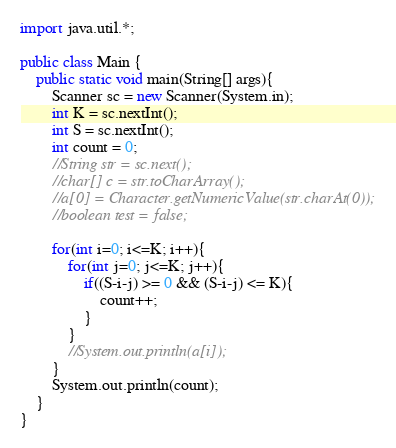<code> <loc_0><loc_0><loc_500><loc_500><_Java_>import java.util.*;

public class Main {
    public static void main(String[] args){
        Scanner sc = new Scanner(System.in);
        int K = sc.nextInt();
        int S = sc.nextInt();
        int count = 0;
        //String str = sc.next();
        //char[] c = str.toCharArray();
        //a[0] = Character.getNumericValue(str.charAt(0));
        //boolean test = false;
        
        for(int i=0; i<=K; i++){
            for(int j=0; j<=K; j++){
                if((S-i-j) >= 0 && (S-i-j) <= K){
                    count++;
                }
            }
            //System.out.println(a[i]);
        }
        System.out.println(count);
    }
}
</code> 